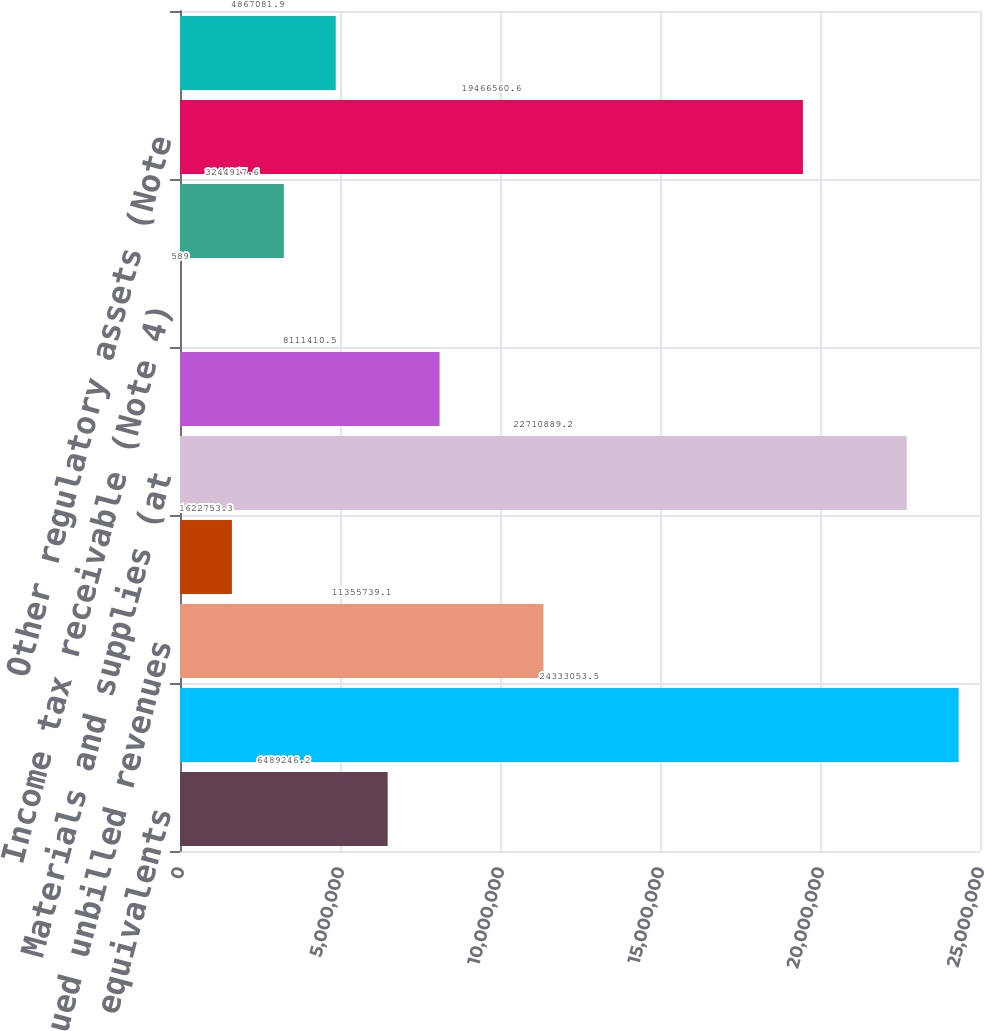<chart> <loc_0><loc_0><loc_500><loc_500><bar_chart><fcel>Cash and cash equivalents<fcel>Customer and other receivables<fcel>Accrued unbilled revenues<fcel>Allowance for doubtful<fcel>Materials and supplies (at<fcel>Fossil fuel (at average cost)<fcel>Income tax receivable (Note 4)<fcel>Assets from risk management<fcel>Other regulatory assets (Note<fcel>Other current assets<nl><fcel>6.48925e+06<fcel>2.43331e+07<fcel>1.13557e+07<fcel>1.62275e+06<fcel>2.27109e+07<fcel>8.11141e+06<fcel>589<fcel>3.24492e+06<fcel>1.94666e+07<fcel>4.86708e+06<nl></chart> 